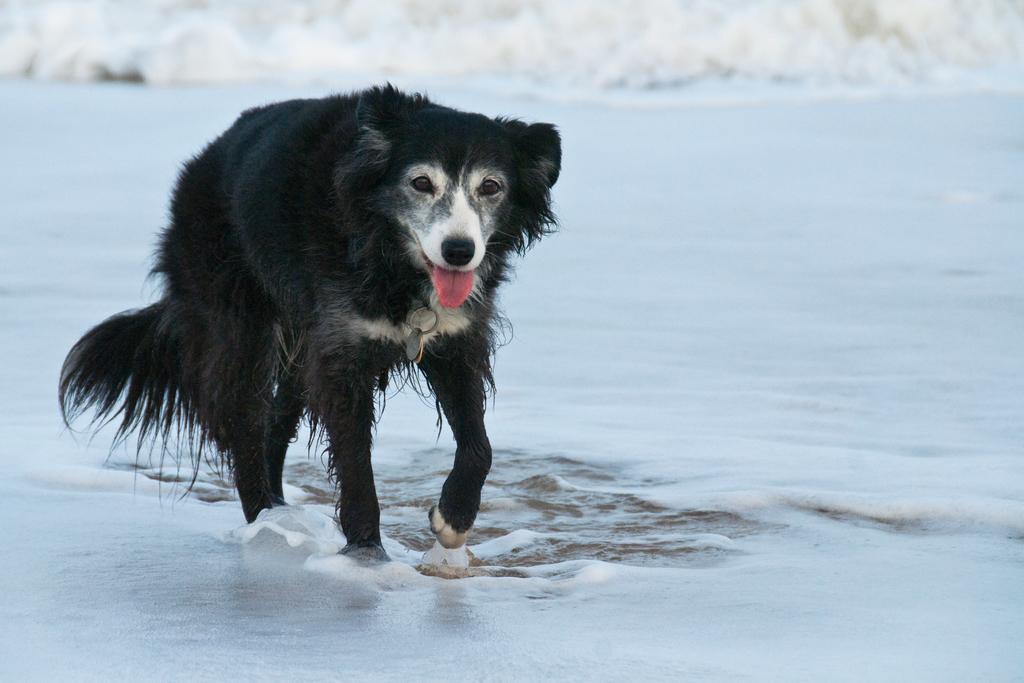Could you give a brief overview of what you see in this image? The picture consists of a dog walking. In the picture there is water. At the top there is a wave approaching. 